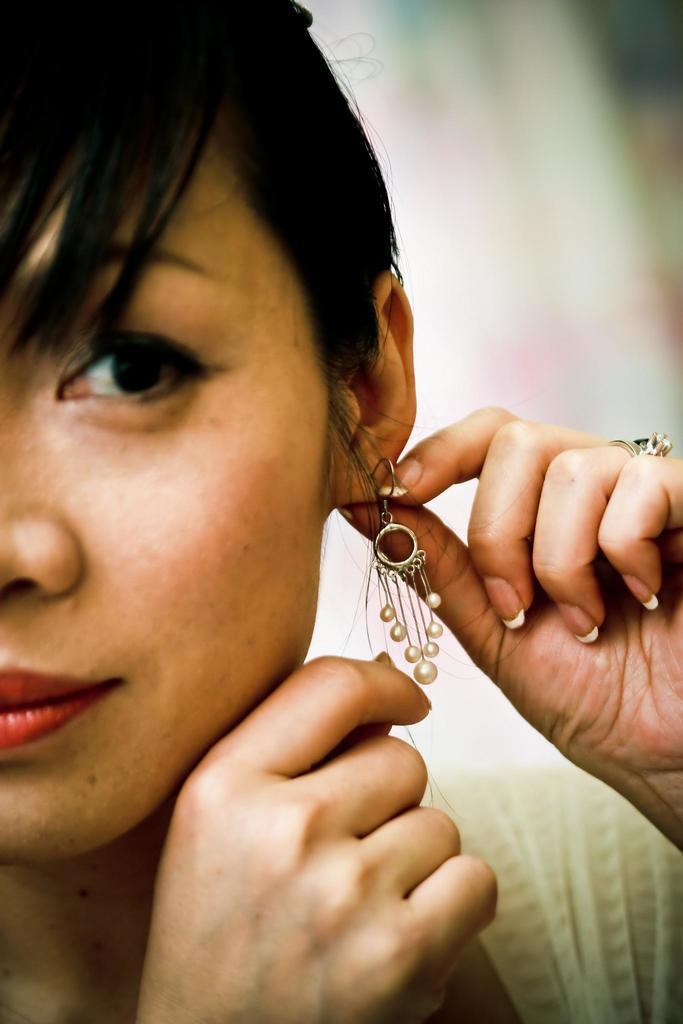Can you describe this image briefly? In this image, I can see the woman. This looks like an earring. The background looks blurry. 